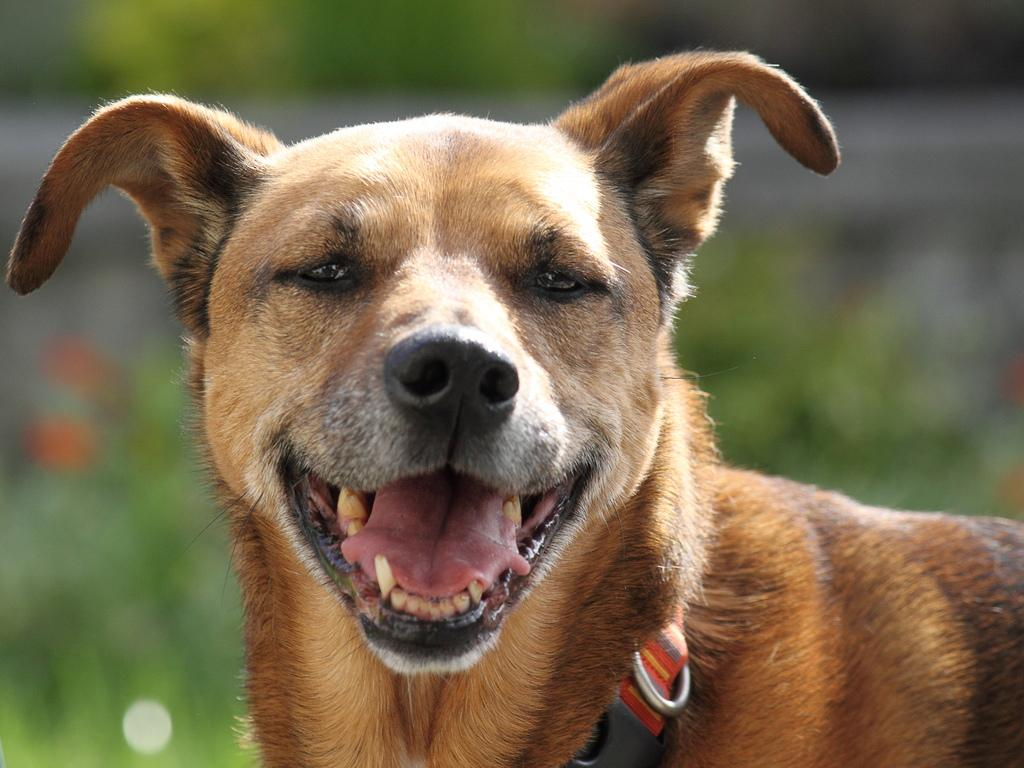What is the main subject in the foreground of the image? There is a dog in the foreground of the image. What is the dog doing in the image? The dog is smiling at someone. What type of box is the dog playing with in the image? There is no box present in the image; the dog is simply smiling at someone. 